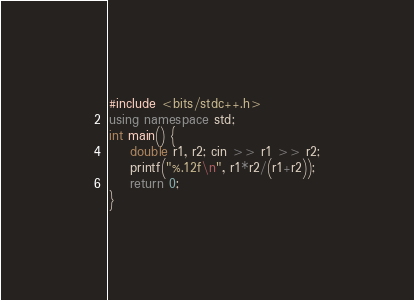Convert code to text. <code><loc_0><loc_0><loc_500><loc_500><_C++_>#include <bits/stdc++.h>
using namespace std;
int main() {
    double r1, r2; cin >> r1 >> r2;
    printf("%.12f\n", r1*r2/(r1+r2));
    return 0;
}</code> 